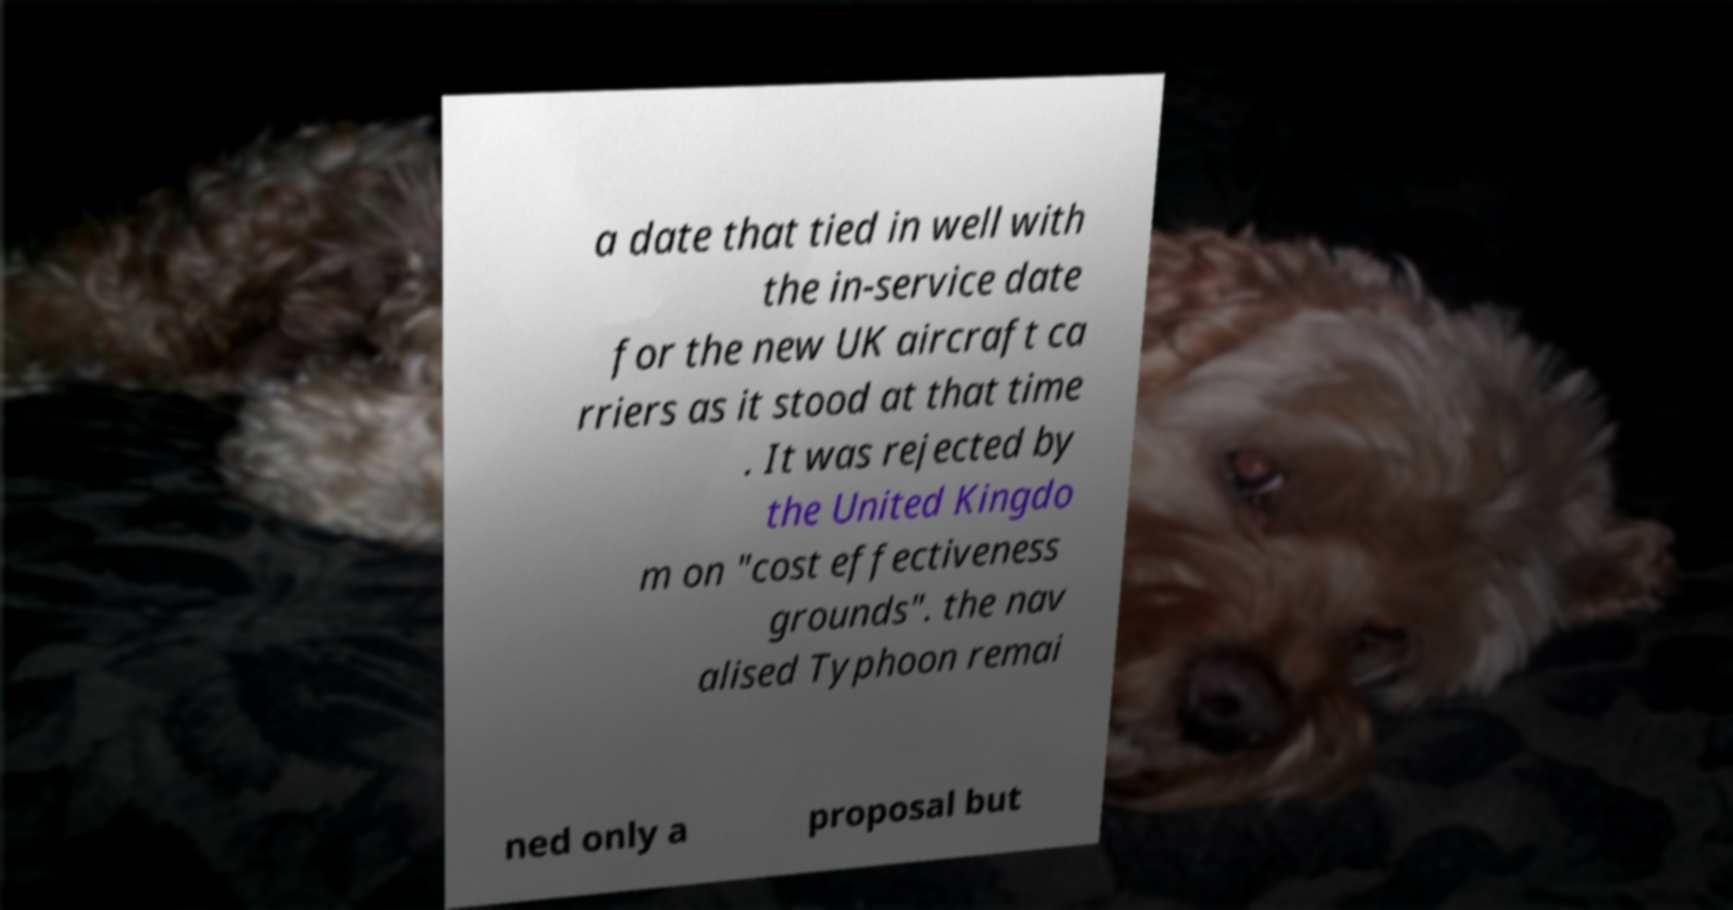Can you read and provide the text displayed in the image?This photo seems to have some interesting text. Can you extract and type it out for me? a date that tied in well with the in-service date for the new UK aircraft ca rriers as it stood at that time . It was rejected by the United Kingdo m on "cost effectiveness grounds". the nav alised Typhoon remai ned only a proposal but 